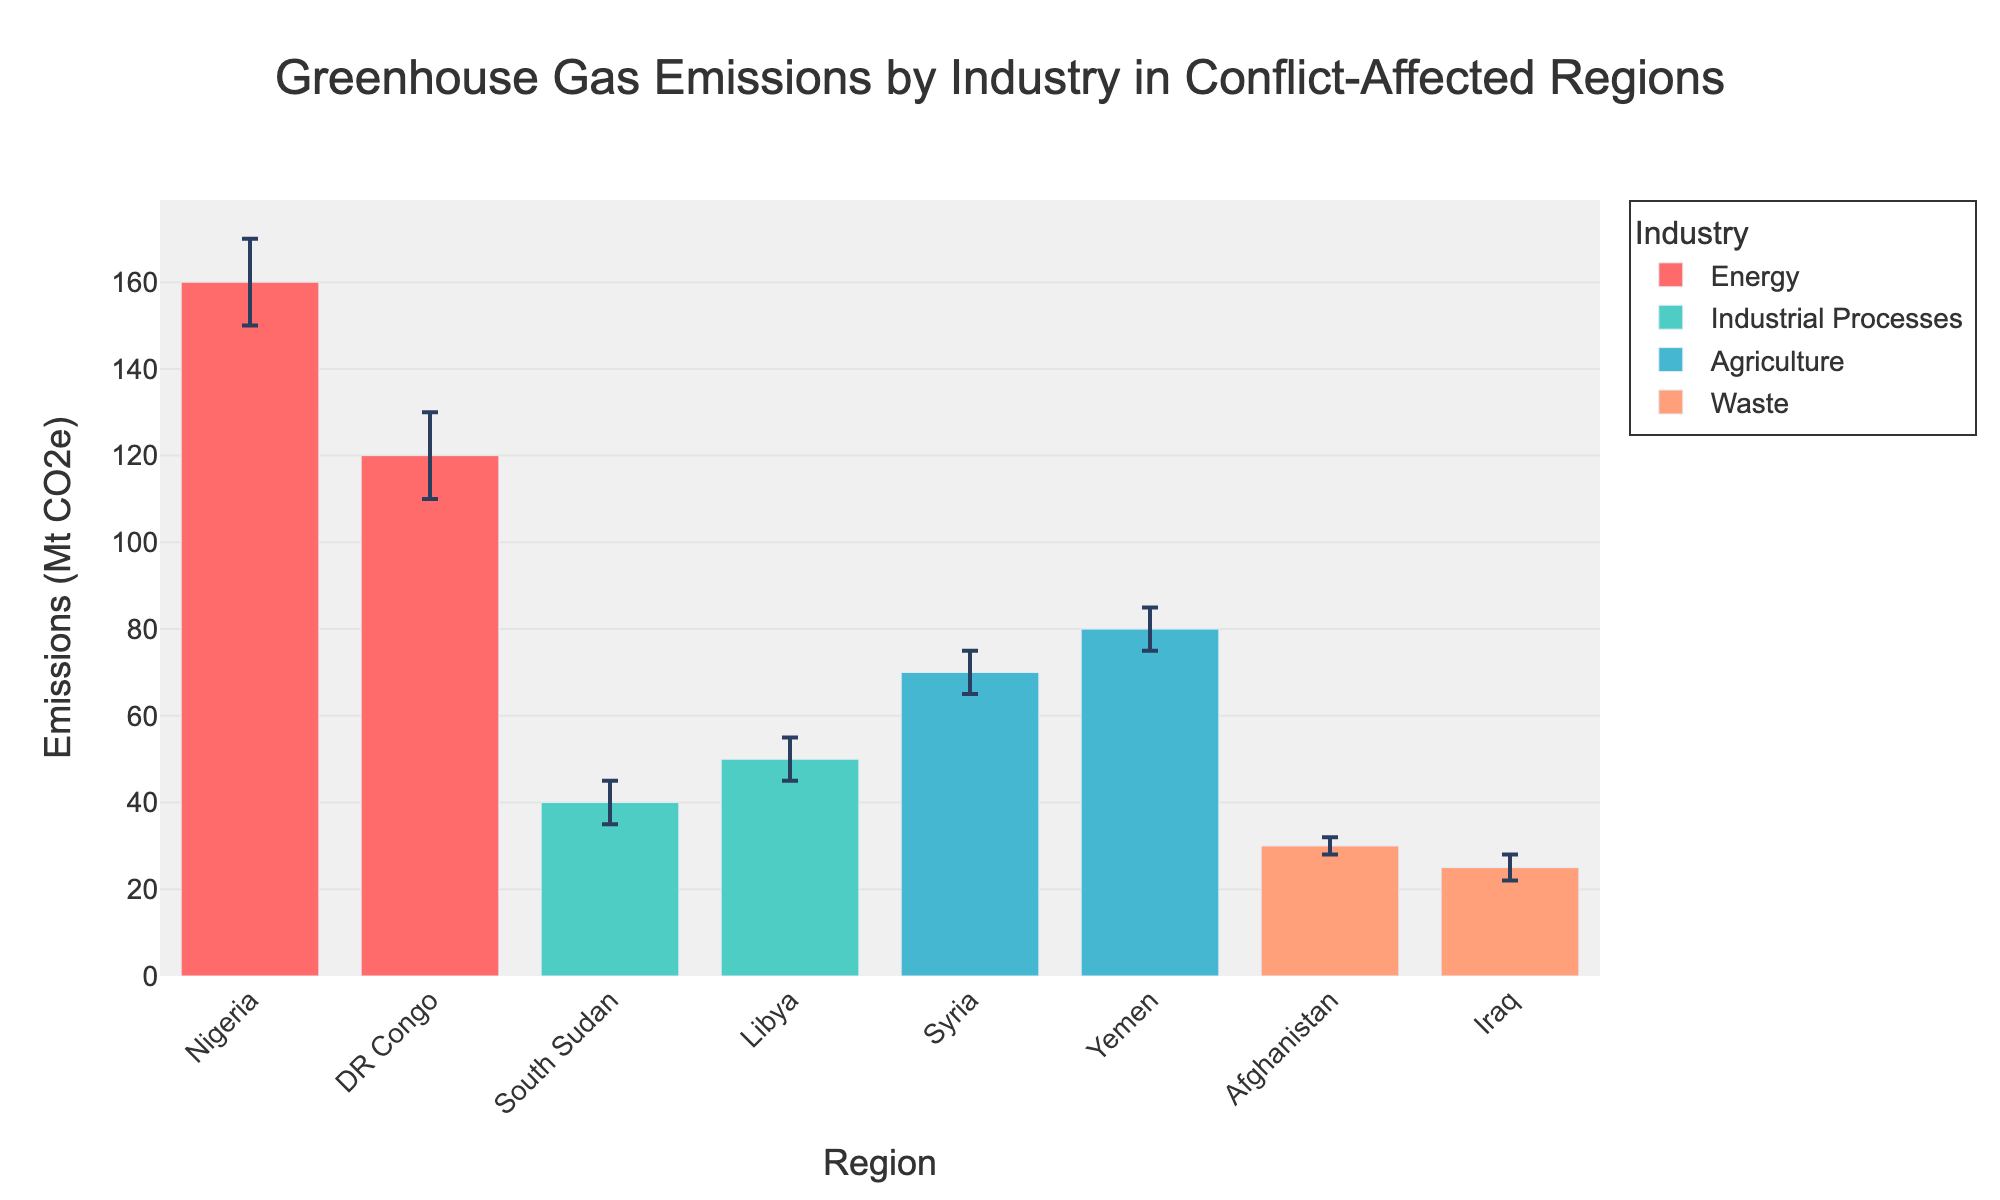What's the title of the chart? The title is placed at the top center of the chart and reads "Greenhouse Gas Emissions by Industry in Conflict-Affected Regions."
Answer: Greenhouse Gas Emissions by Industry in Conflict-Affected Regions Which region has the highest emissions in the Energy industry? By looking at the bar heights and the region labels on the x-axis, the tallest bar under the Energy category is for Nigeria, showing the highest emissions.
Answer: Nigeria What's the difference in greenhouse gas emissions between Agriculture in Syria and Yemen? From the height of the bars, Syria has 70 Mt CO2e and Yemen has 80 Mt CO2e. The difference is 80 - 70.
Answer: 10 Mt CO2e Which industry has the least emissions in Iraq? Examining the bars specifically for the region labeled Iraq, the industry associated with that region is Waste, indicated by the height of the bar representing 25 Mt CO2e.
Answer: Waste What is the uncertainty range for Industrial Processes in Libya? The upper bound for Libya is 55 Mt CO2e and the lower bound is 45 Mt CO2e. The uncertainty range is derived by subtracting the lower bound from the upper bound.
Answer: 10 Mt CO2e Which industry has the most significant upper bound uncertainty? To find the largest upper bound uncertainty, we compare the differences between the upper bound and the average emissions value for each industry. Energy in Nigeria has the highest uncertainty with an upper bound of 170 Mt CO2e and an emission of 160 Mt CO2e, giving a difference of 10 Mt CO2e.
Answer: Energy Is the lower bound of Industrial Processes in South Sudan greater than the lower bound of Waste in Afghanistan? Comparing both bars, the lower bound for Industrial Processes in South Sudan is 35 Mt CO2e, while for Waste in Afghanistan, it’s 28 Mt CO2e. Since 35 is greater than 28, the answer is yes.
Answer: Yes What is the sum of emissions for Waste in Iraq and Industrial Processes in Libya? The emissions are 25 Mt CO2e for Waste in Iraq and 50 Mt CO2e for Industrial Processes in Libya. Adding both values gives 25 + 50.
Answer: 75 Mt CO2e How does the uncertainty in Agriculture in Syria compare to the uncertainty in Agriculture in Yemen? For Syria, the uncertainty range is 10 Mt CO2e (Upper 75 - Lower 65). For Yemen, the uncertainty range is 10 Mt CO2e (Upper 85 - Lower 75). Both have the same uncertainty.
Answer: Same Which region has the lowest upper bound of emissions in any industry? Checking all the upper bound values, Waste in Iraq has the lowest upper bound emitting 28 Mt CO2e.
Answer: Iraq 